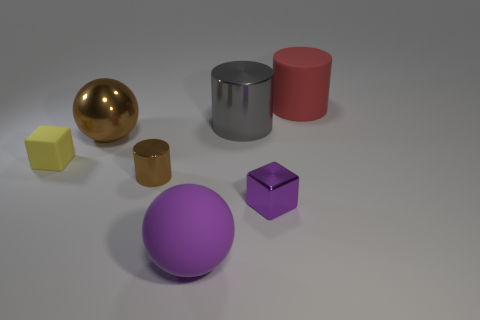Subtract all rubber cylinders. How many cylinders are left? 2 Subtract all yellow cubes. How many cubes are left? 1 Subtract all blocks. How many objects are left? 5 Subtract 2 cylinders. How many cylinders are left? 1 Subtract all gray things. Subtract all big red cylinders. How many objects are left? 5 Add 3 large matte things. How many large matte things are left? 5 Add 1 cyan metallic cubes. How many cyan metallic cubes exist? 1 Add 1 brown metal cylinders. How many objects exist? 8 Subtract 1 purple spheres. How many objects are left? 6 Subtract all cyan blocks. Subtract all cyan cylinders. How many blocks are left? 2 